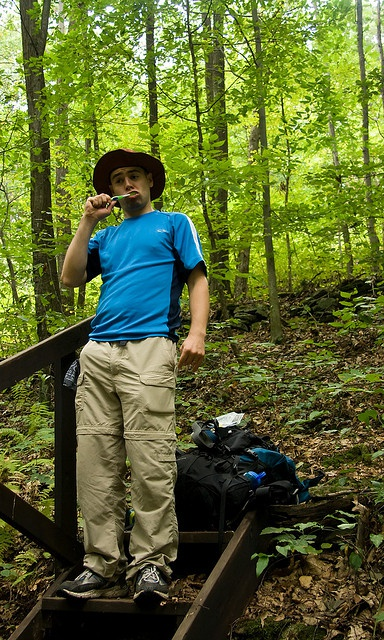Describe the objects in this image and their specific colors. I can see people in lavender, black, tan, olive, and teal tones, backpack in lavender, black, gray, darkgreen, and ivory tones, and toothbrush in lavender, black, darkgreen, beige, and khaki tones in this image. 